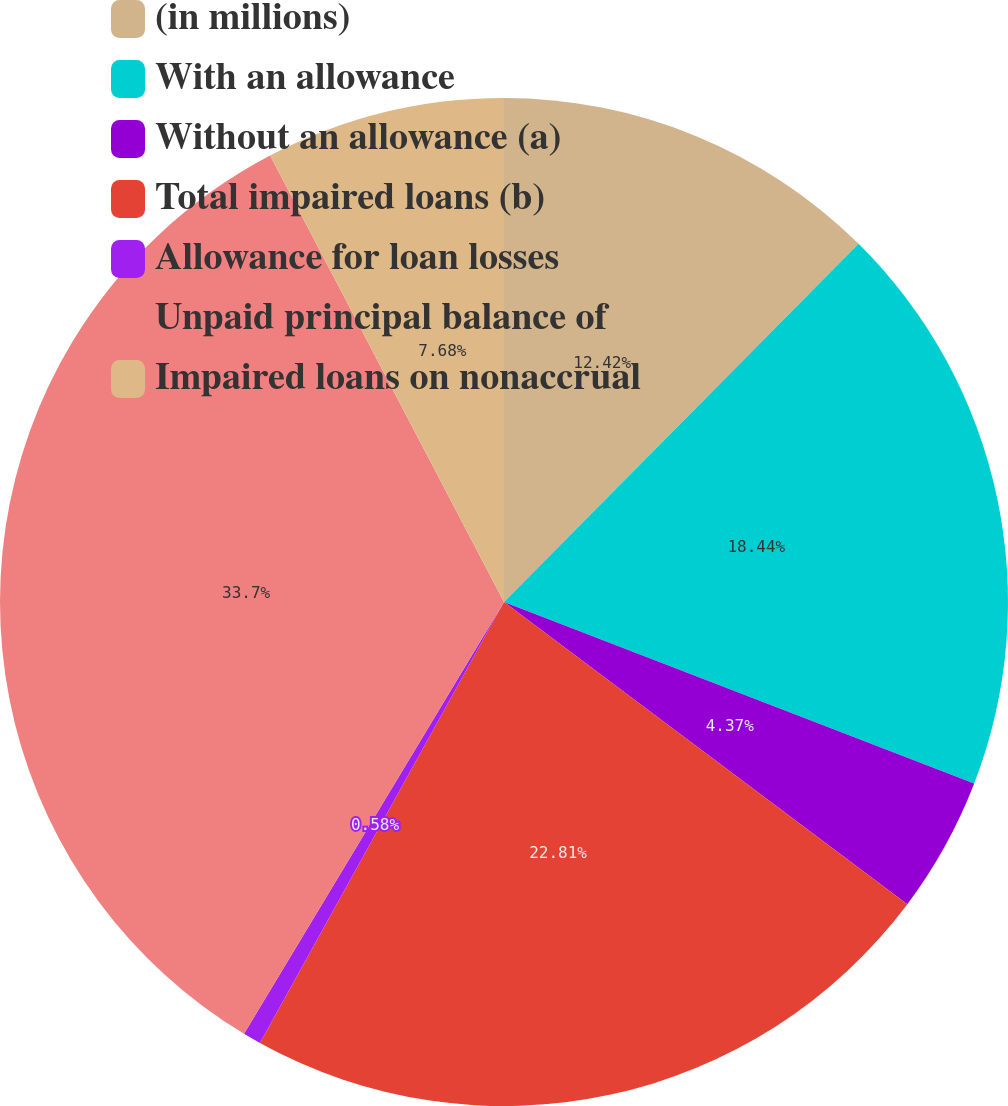Convert chart to OTSL. <chart><loc_0><loc_0><loc_500><loc_500><pie_chart><fcel>(in millions)<fcel>With an allowance<fcel>Without an allowance (a)<fcel>Total impaired loans (b)<fcel>Allowance for loan losses<fcel>Unpaid principal balance of<fcel>Impaired loans on nonaccrual<nl><fcel>12.42%<fcel>18.44%<fcel>4.37%<fcel>22.81%<fcel>0.58%<fcel>33.69%<fcel>7.68%<nl></chart> 